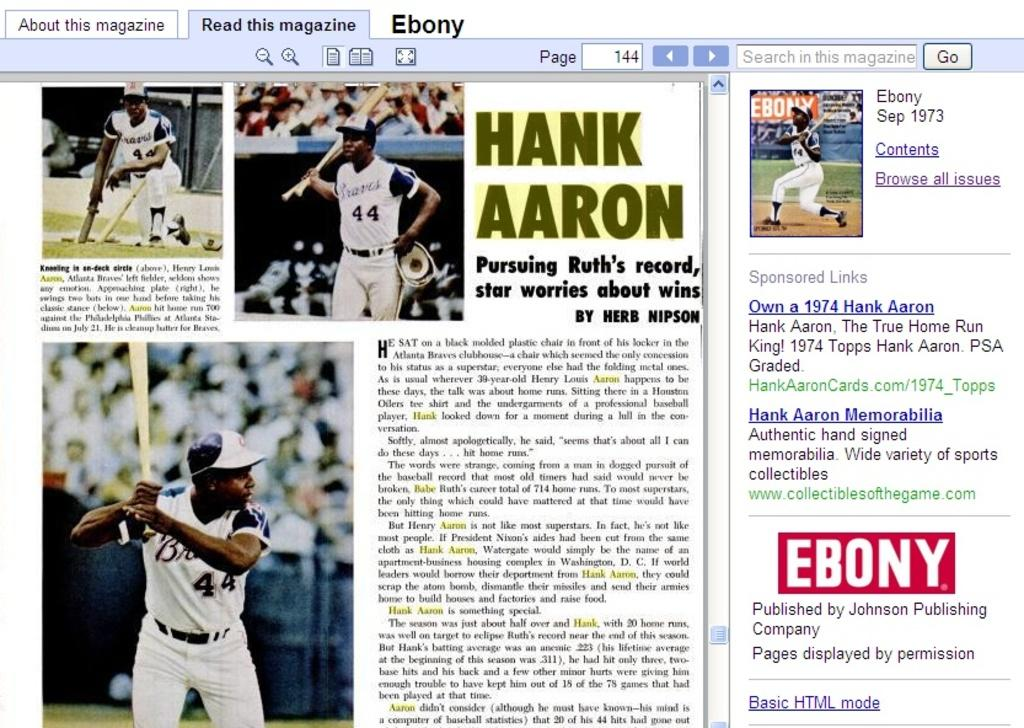<image>
Offer a succinct explanation of the picture presented. Ebony website is displaying an article about Hank Aaron. 